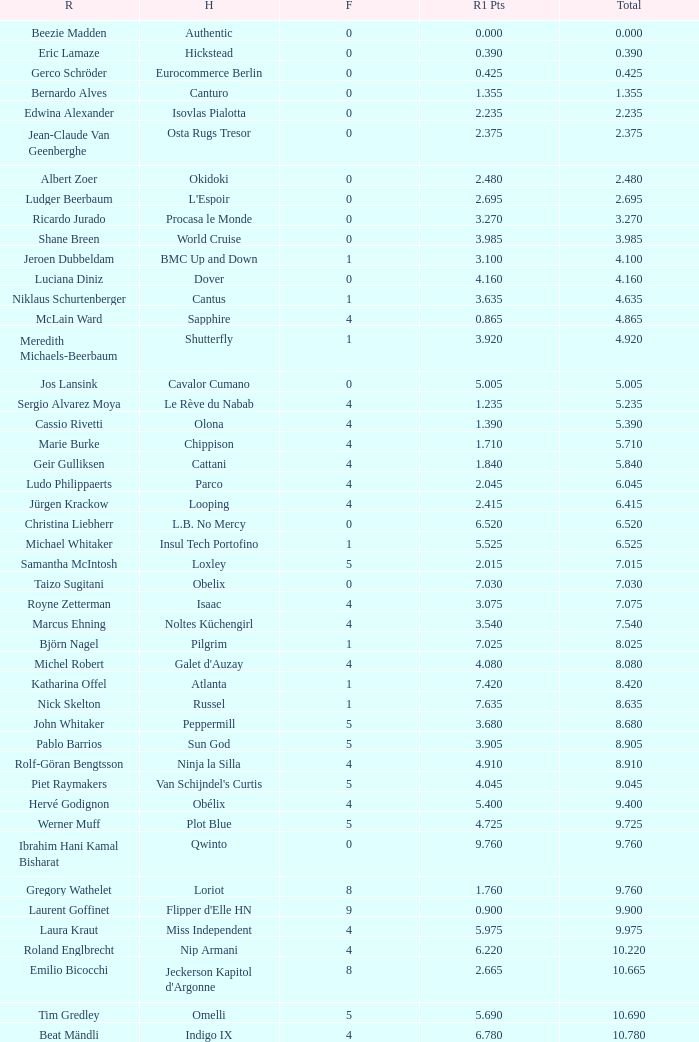Tell me the rider that had round 1 points of 7.465 and total more than 16.615 Manuel Fernandez Saro. 